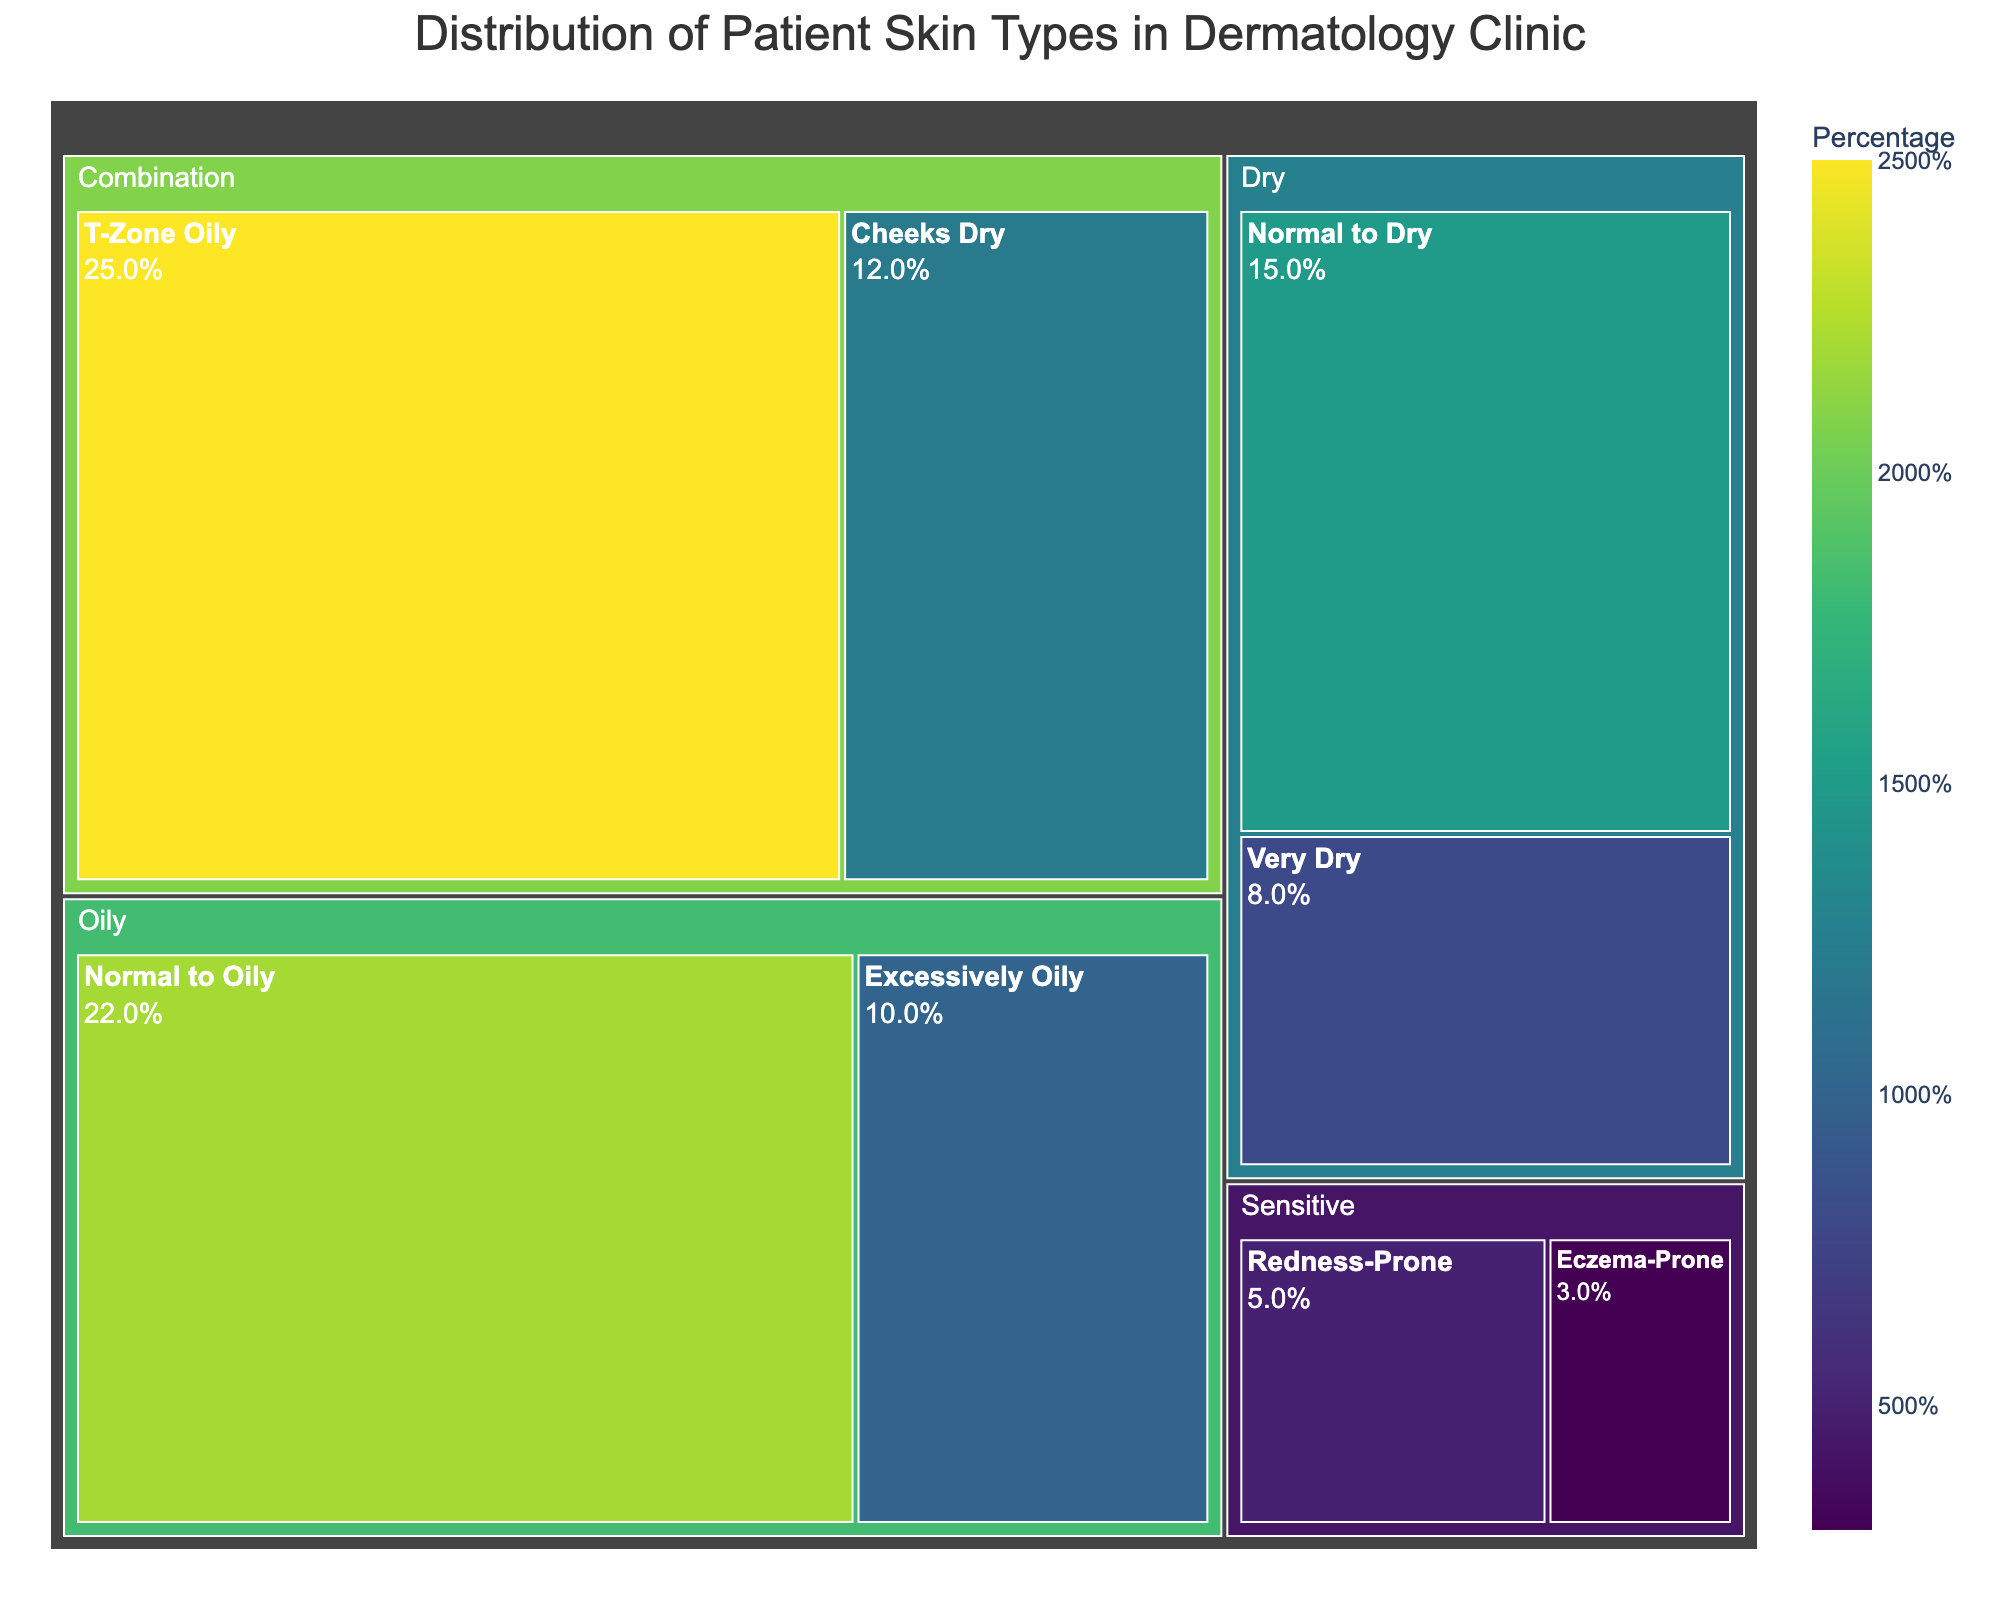What is the title of the treemap? The information is prominently displayed at the top of the treemap in a larger font size.
Answer: Distribution of Patient Skin Types in Dermatology Clinic What category has the highest percentage? By examining the sizes of the treemap boxes, the largest one falls under the 'Combination' category.
Answer: Combination How many skin types fall under the 'Sensitive' category? Look for the sensitive category in the treemap and count the skin types listed under it.
Answer: 2 What is the percentage for "Normal to Oily" skin type? Find the "Normal to Oily" skin type, which is categorized under 'Oily', and read its corresponding percentage.
Answer: 22% Which skin type has the smallest percentage? Look for the smallest box in the treemap, which represents the "Eczema-Prone" skin type under the 'Sensitive' category.
Answer: Eczema-Prone What is the combined percentage of all skin types under the 'Dry' category? Add the percentages for the "Normal to Dry" and "Very Dry" skin types under the 'Dry' category (15% + 8%).
Answer: 23% Is the percentage of "Excessively Oily" skin type higher than the "Very Dry" skin type? Compare the percentages for "Excessively Oily" (10%) and "Very Dry" (8%) skin types.
Answer: Yes Which category has more variety in skin types, 'Combination' or 'Oily'? Compare the number of skin types under each category - 'Combination' (T-Zone Oily and Cheeks Dry) and 'Oily' (Normal to Oily and Excessively Oily).
Answer: Combination What is the difference in percentage between the "T-Zone Oily" and "Cheeks Dry" skin types? Subtract the percentage for "Cheeks Dry" (12%) from "T-Zone Oily" (25%).
Answer: 13% Rank the skin types under the 'Oily' category from highest to lowest percentage. Arrange the percentages of the skin types within the 'Oily' category in descending order: "Normal to Oily" (22%) and "Excessively Oily" (10%).
Answer: Normal to Oily, Excessively Oily 